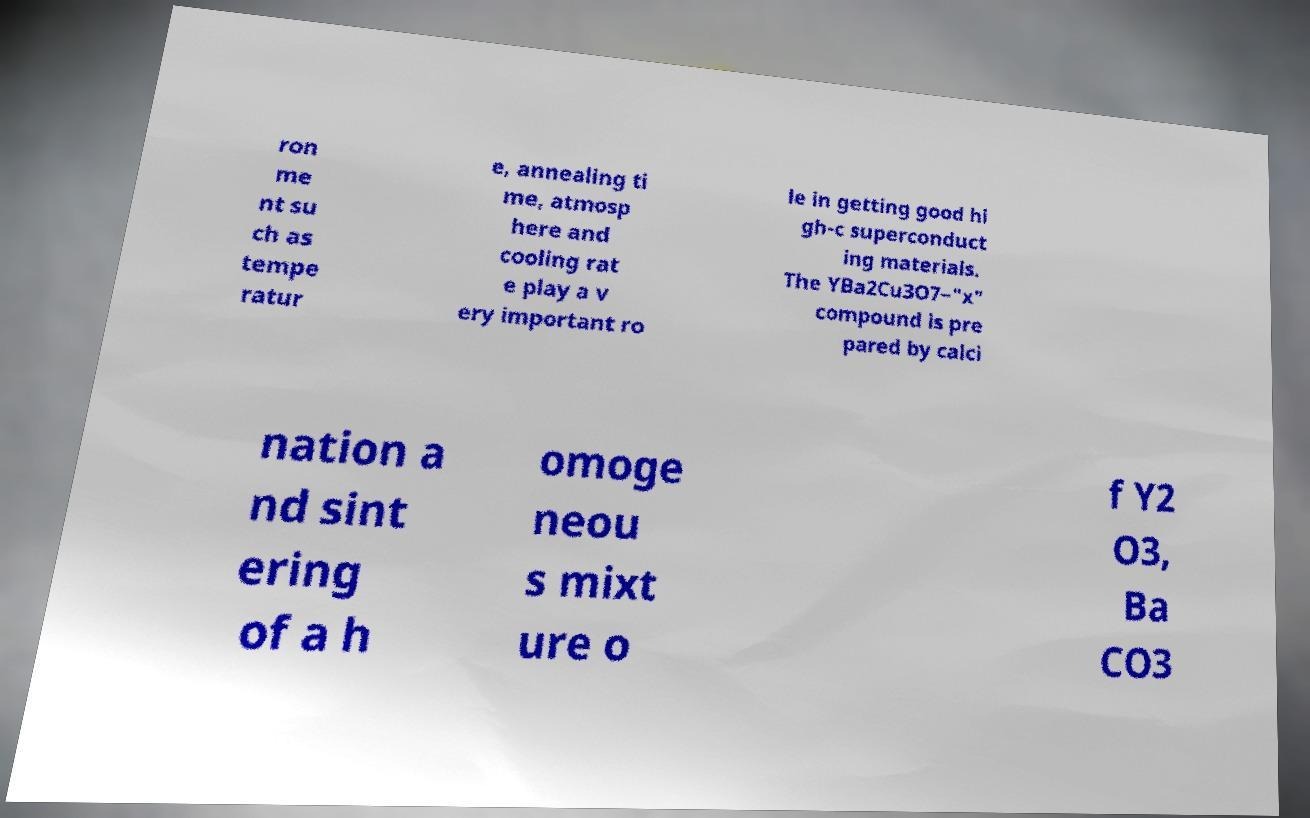Can you read and provide the text displayed in the image?This photo seems to have some interesting text. Can you extract and type it out for me? ron me nt su ch as tempe ratur e, annealing ti me, atmosp here and cooling rat e play a v ery important ro le in getting good hi gh-c superconduct ing materials. The YBa2Cu3O7−"x" compound is pre pared by calci nation a nd sint ering of a h omoge neou s mixt ure o f Y2 O3, Ba CO3 